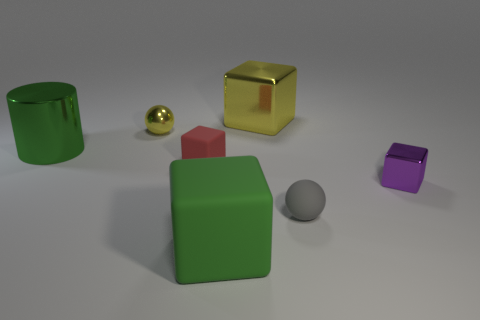Which objects are closest to the center of the image? The red cube and the grey sphere appear to be closest to the center of the image. 